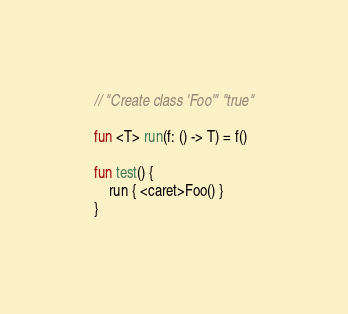Convert code to text. <code><loc_0><loc_0><loc_500><loc_500><_Kotlin_>// "Create class 'Foo'" "true"

fun <T> run(f: () -> T) = f()

fun test() {
    run { <caret>Foo() }
}</code> 